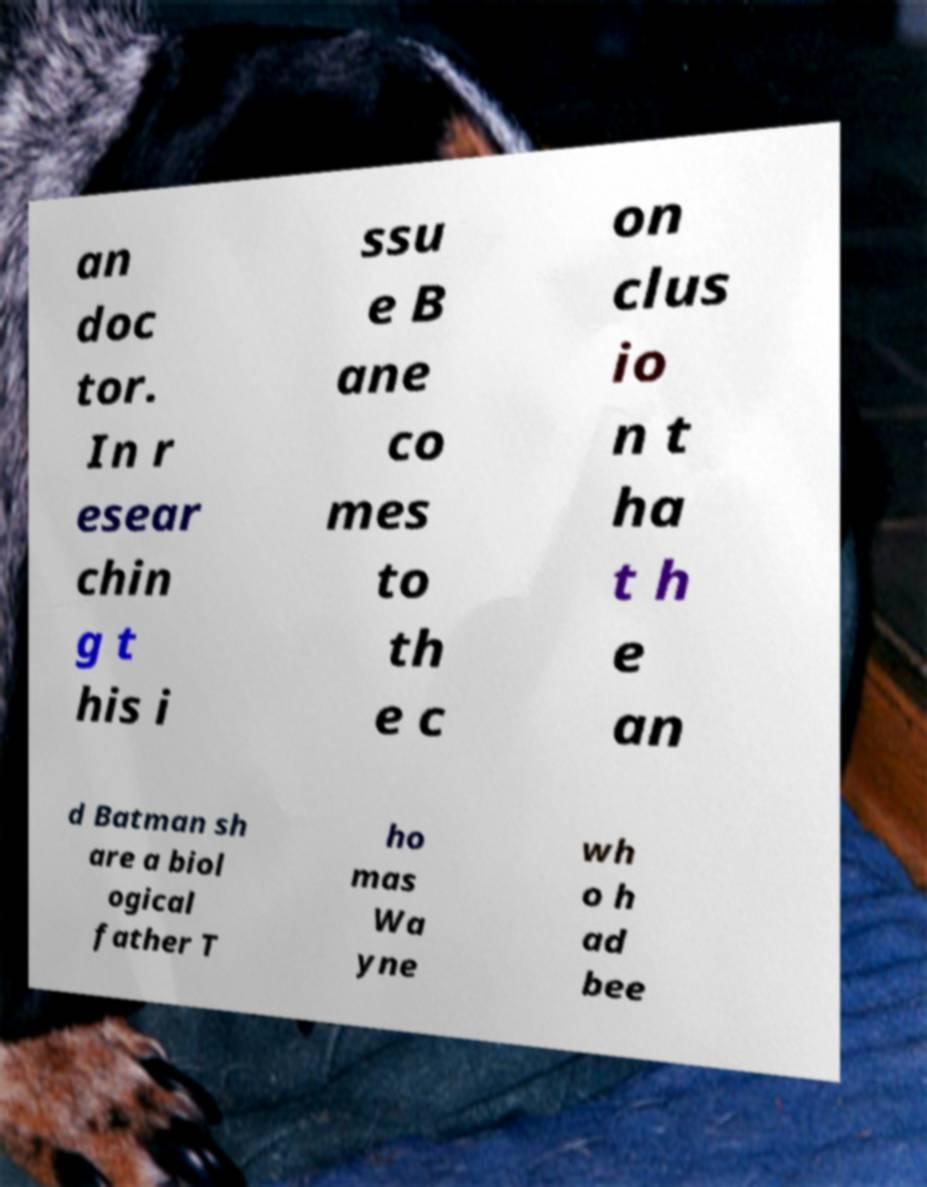Please identify and transcribe the text found in this image. an doc tor. In r esear chin g t his i ssu e B ane co mes to th e c on clus io n t ha t h e an d Batman sh are a biol ogical father T ho mas Wa yne wh o h ad bee 